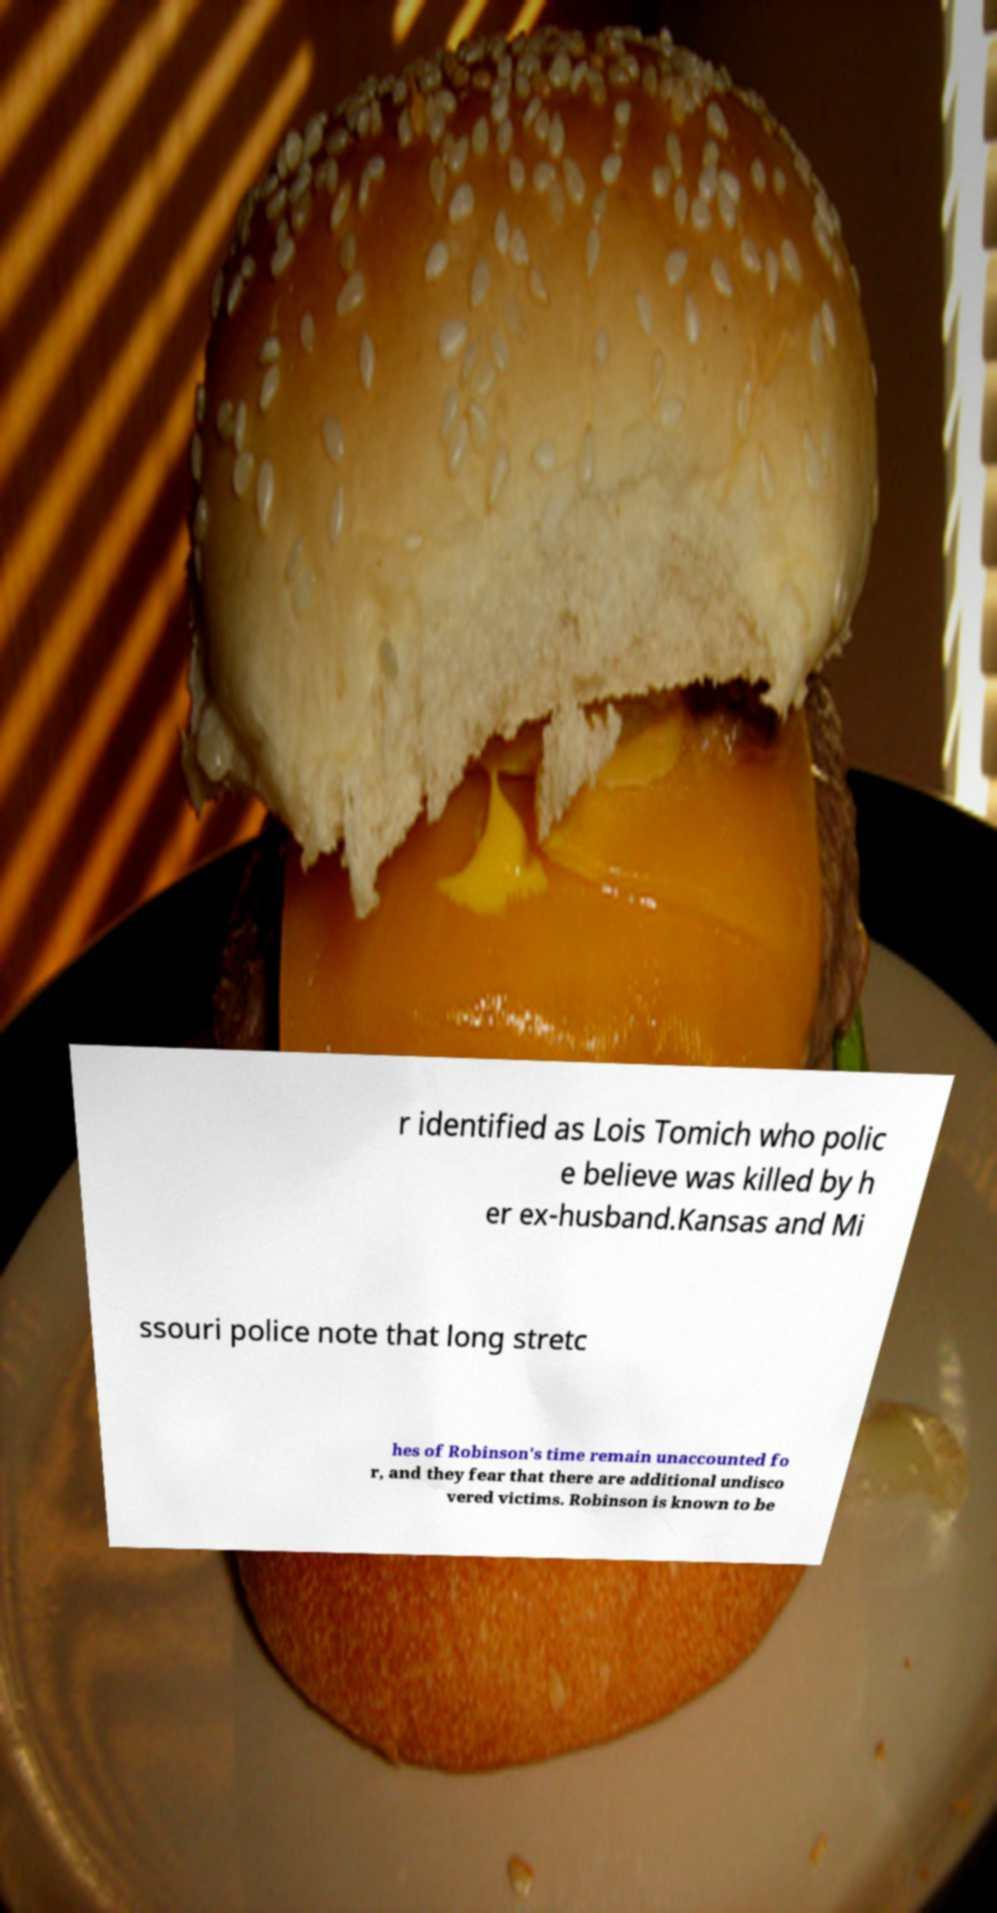What messages or text are displayed in this image? I need them in a readable, typed format. r identified as Lois Tomich who polic e believe was killed by h er ex-husband.Kansas and Mi ssouri police note that long stretc hes of Robinson's time remain unaccounted fo r, and they fear that there are additional undisco vered victims. Robinson is known to be 